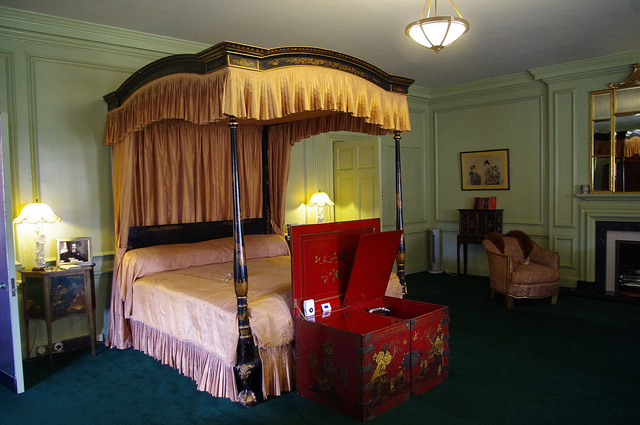<image>What kind of bed is in the picture? I am not sure what kind of bed is in the picture. It may be a canopy, poster or there may not be any bed in the picture. What kind of bed is in the picture? I am not sure what kind of bed is in the picture. It can be a canopy bed or a poster bed. 